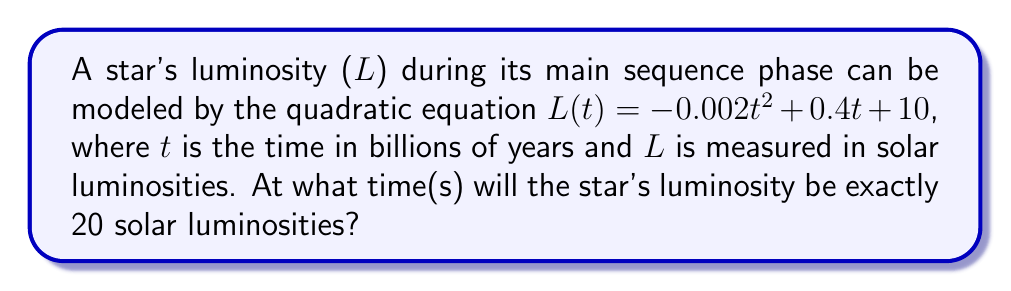Give your solution to this math problem. To solve this problem, we need to find the value(s) of t where L(t) = 20. Let's approach this step-by-step:

1) We start with the equation:
   $L(t) = -0.002t^2 + 0.4t + 10$

2) We want to find when L(t) = 20, so we set up the equation:
   $20 = -0.002t^2 + 0.4t + 10$

3) Subtract 10 from both sides:
   $10 = -0.002t^2 + 0.4t$

4) Multiply all terms by -500 to eliminate fractions:
   $-5000 = t^2 - 200t$

5) Rearrange to standard form:
   $t^2 - 200t + 5000 = 0$

6) This is a quadratic equation in the form $at^2 + bt + c = 0$, where:
   $a = 1$
   $b = -200$
   $c = 5000$

7) We can solve this using the quadratic formula: $t = \frac{-b \pm \sqrt{b^2 - 4ac}}{2a}$

8) Substituting our values:
   $t = \frac{200 \pm \sqrt{(-200)^2 - 4(1)(5000)}}{2(1)}$

9) Simplify:
   $t = \frac{200 \pm \sqrt{40000 - 20000}}{2} = \frac{200 \pm \sqrt{20000}}{2}$

10) Simplify further:
    $t = \frac{200 \pm 141.4214}{2}$

11) This gives us two solutions:
    $t_1 = \frac{200 + 141.4214}{2} \approx 170.7107$
    $t_2 = \frac{200 - 141.4214}{2} \approx 29.2893$

Therefore, the star's luminosity will be exactly 20 solar luminosities at approximately 29.2893 and 170.7107 billion years after entering the main sequence.
Answer: The star's luminosity will be 20 solar luminosities at $t \approx 29.2893$ billion years and $t \approx 170.7107$ billion years. 